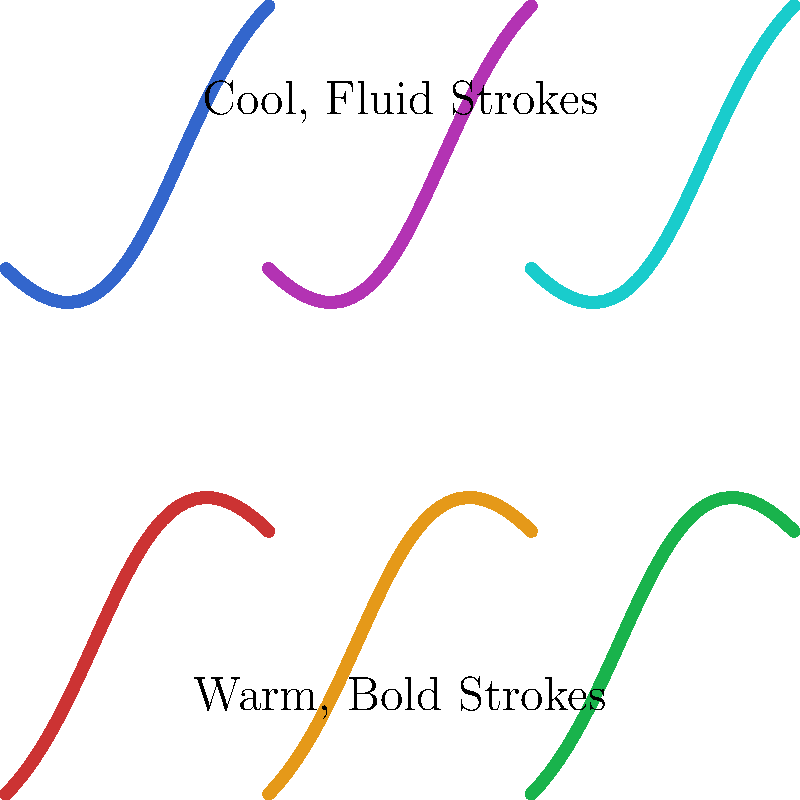Based on the color palette and brush strokes shown in the image, which artistic style is more likely represented in the upper half of the mural sample? To identify the artistic style based on color palette and brush strokes, we need to analyze the following aspects:

1. Color Palette:
   - Upper half: Uses warm colors (reds, oranges, greens)
   - Lower half: Uses cool colors (blues, purples, teals)

2. Brush Strokes:
   - Upper half: Bold, angular strokes with sharp changes in direction
   - Lower half: Fluid, curved strokes with smooth transitions

3. Artistic Style Analysis:
   - The warm color palette in the upper half is often associated with Expressionism or Fauvism
   - The bold, angular brush strokes are characteristic of Expressionism

4. Comparison:
   - Expressionism: Known for bold colors and strong, angular brush strokes to convey emotions
   - Fauvism: Uses bright, non-naturalistic colors but typically with smoother brush strokes

5. Conclusion:
   Based on the combination of warm colors and bold, angular brush strokes, the upper half of the mural sample is more likely to represent Expressionism.
Answer: Expressionism 